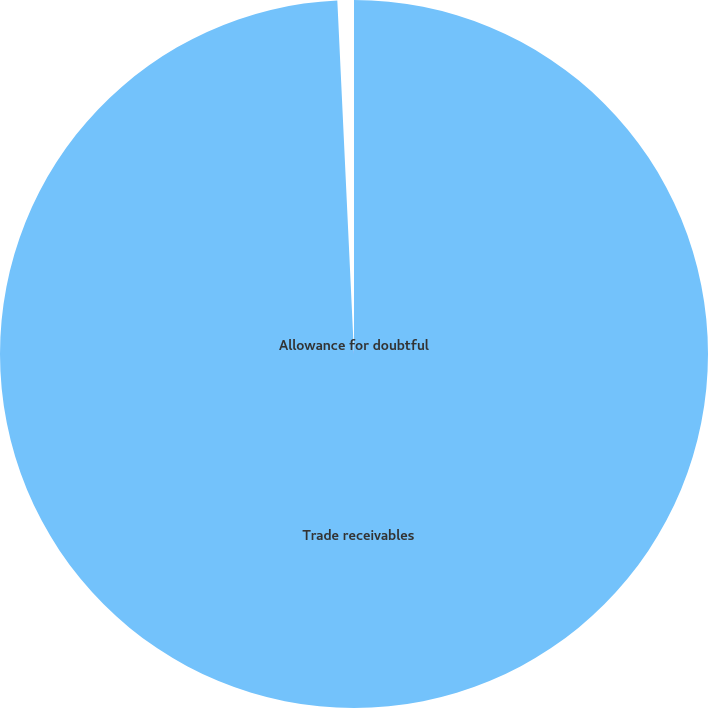<chart> <loc_0><loc_0><loc_500><loc_500><pie_chart><fcel>Trade receivables<fcel>Allowance for doubtful<nl><fcel>99.25%<fcel>0.75%<nl></chart> 